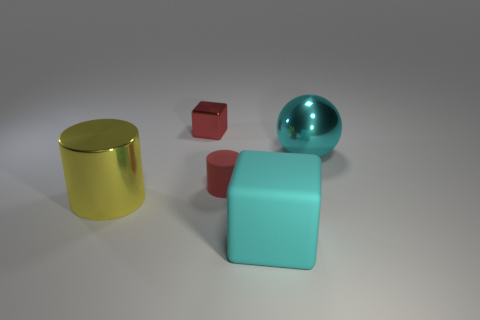Are there any big cubes left of the red metal cube?
Offer a terse response. No. There is a small rubber cylinder; does it have the same color as the thing that is in front of the large yellow object?
Offer a very short reply. No. What is the color of the cylinder that is on the right side of the small object that is behind the small object that is in front of the cyan shiny thing?
Your answer should be compact. Red. Are there any other yellow metallic things that have the same shape as the small shiny object?
Your response must be concise. No. The matte thing that is the same size as the cyan metallic object is what color?
Offer a very short reply. Cyan. What is the material of the small thing that is behind the red rubber cylinder?
Provide a short and direct response. Metal. Is the shape of the thing in front of the yellow cylinder the same as the tiny thing that is to the right of the small red metallic thing?
Keep it short and to the point. No. Are there an equal number of cylinders that are in front of the big yellow object and yellow rubber things?
Offer a terse response. Yes. How many tiny things are the same material as the large yellow thing?
Make the answer very short. 1. The big sphere that is made of the same material as the red cube is what color?
Your response must be concise. Cyan. 